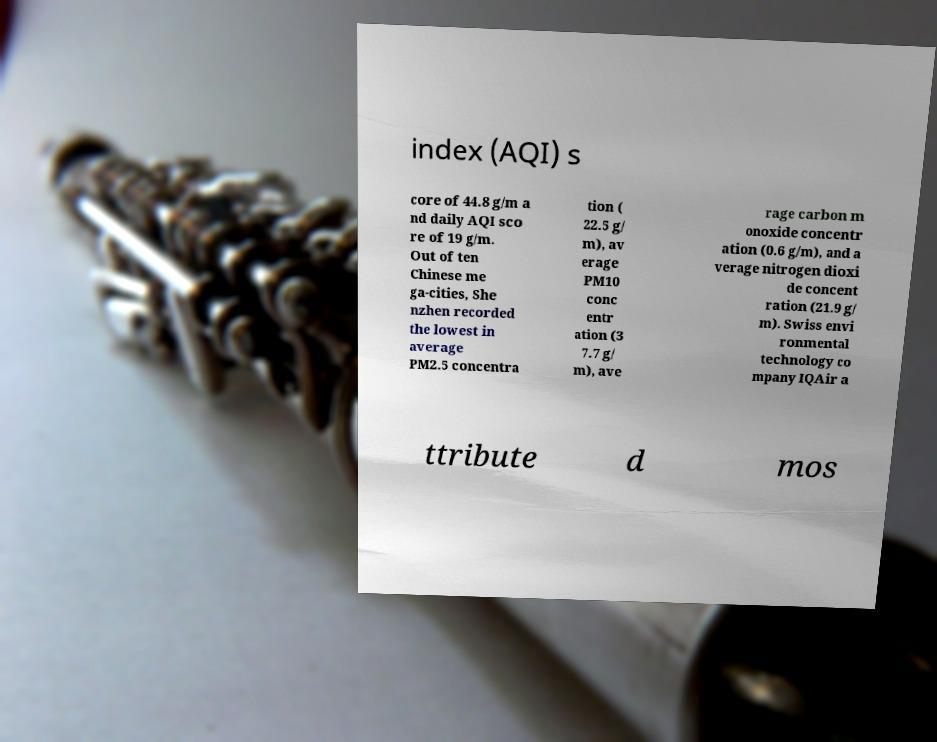What messages or text are displayed in this image? I need them in a readable, typed format. index (AQI) s core of 44.8 g/m a nd daily AQI sco re of 19 g/m. Out of ten Chinese me ga-cities, She nzhen recorded the lowest in average PM2.5 concentra tion ( 22.5 g/ m), av erage PM10 conc entr ation (3 7.7 g/ m), ave rage carbon m onoxide concentr ation (0.6 g/m), and a verage nitrogen dioxi de concent ration (21.9 g/ m). Swiss envi ronmental technology co mpany IQAir a ttribute d mos 